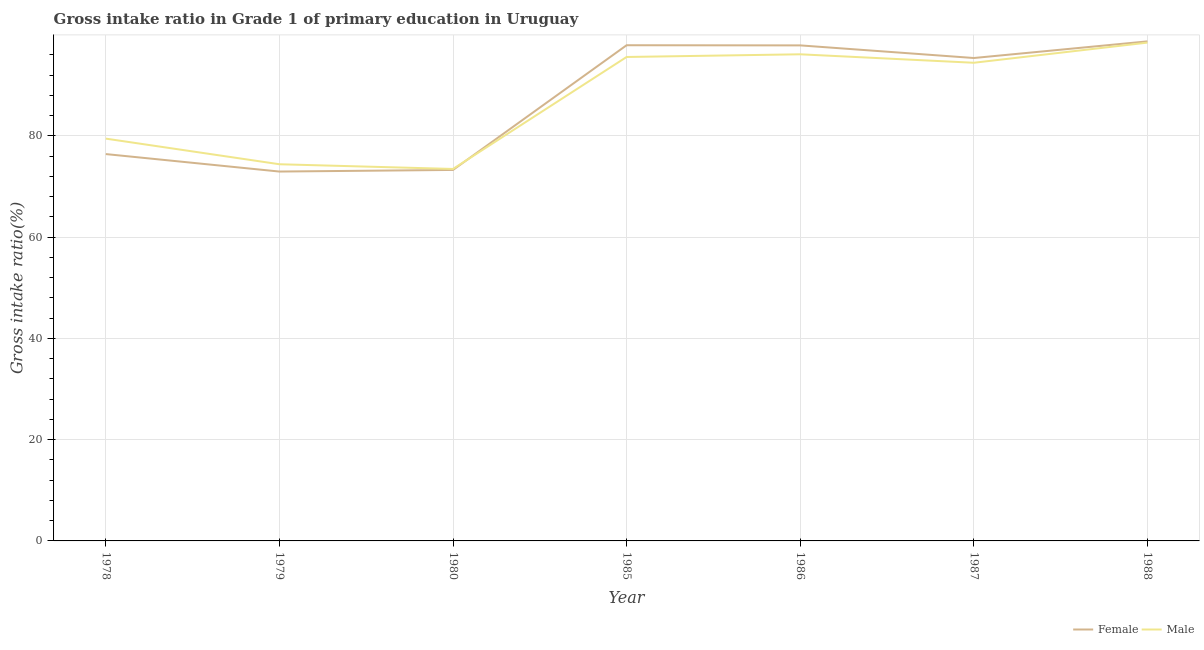What is the gross intake ratio(male) in 1980?
Provide a short and direct response. 73.45. Across all years, what is the maximum gross intake ratio(female)?
Make the answer very short. 98.64. Across all years, what is the minimum gross intake ratio(male)?
Offer a terse response. 73.45. In which year was the gross intake ratio(male) minimum?
Provide a succinct answer. 1980. What is the total gross intake ratio(male) in the graph?
Provide a succinct answer. 611.72. What is the difference between the gross intake ratio(female) in 1978 and that in 1988?
Make the answer very short. -22.25. What is the difference between the gross intake ratio(female) in 1980 and the gross intake ratio(male) in 1985?
Ensure brevity in your answer.  -22.31. What is the average gross intake ratio(female) per year?
Provide a succinct answer. 87.47. In the year 1980, what is the difference between the gross intake ratio(male) and gross intake ratio(female)?
Your answer should be very brief. 0.19. What is the ratio of the gross intake ratio(female) in 1978 to that in 1985?
Your answer should be very brief. 0.78. What is the difference between the highest and the second highest gross intake ratio(female)?
Your answer should be compact. 0.76. What is the difference between the highest and the lowest gross intake ratio(male)?
Ensure brevity in your answer.  24.95. Is the sum of the gross intake ratio(female) in 1978 and 1986 greater than the maximum gross intake ratio(male) across all years?
Ensure brevity in your answer.  Yes. Is the gross intake ratio(male) strictly greater than the gross intake ratio(female) over the years?
Provide a succinct answer. No. How many lines are there?
Offer a very short reply. 2. How many years are there in the graph?
Keep it short and to the point. 7. What is the difference between two consecutive major ticks on the Y-axis?
Make the answer very short. 20. Are the values on the major ticks of Y-axis written in scientific E-notation?
Ensure brevity in your answer.  No. Does the graph contain any zero values?
Give a very brief answer. No. Does the graph contain grids?
Your response must be concise. Yes. Where does the legend appear in the graph?
Keep it short and to the point. Bottom right. How many legend labels are there?
Provide a succinct answer. 2. How are the legend labels stacked?
Your answer should be compact. Horizontal. What is the title of the graph?
Offer a very short reply. Gross intake ratio in Grade 1 of primary education in Uruguay. Does "Primary" appear as one of the legend labels in the graph?
Offer a terse response. No. What is the label or title of the X-axis?
Keep it short and to the point. Year. What is the label or title of the Y-axis?
Make the answer very short. Gross intake ratio(%). What is the Gross intake ratio(%) in Female in 1978?
Provide a short and direct response. 76.39. What is the Gross intake ratio(%) of Male in 1978?
Offer a terse response. 79.44. What is the Gross intake ratio(%) of Female in 1979?
Keep it short and to the point. 72.94. What is the Gross intake ratio(%) in Male in 1979?
Provide a short and direct response. 74.38. What is the Gross intake ratio(%) in Female in 1980?
Provide a short and direct response. 73.25. What is the Gross intake ratio(%) of Male in 1980?
Your answer should be compact. 73.45. What is the Gross intake ratio(%) in Female in 1985?
Offer a terse response. 97.88. What is the Gross intake ratio(%) of Male in 1985?
Provide a short and direct response. 95.56. What is the Gross intake ratio(%) of Female in 1986?
Offer a terse response. 97.85. What is the Gross intake ratio(%) in Male in 1986?
Make the answer very short. 96.09. What is the Gross intake ratio(%) in Female in 1987?
Your answer should be very brief. 95.36. What is the Gross intake ratio(%) of Male in 1987?
Provide a succinct answer. 94.42. What is the Gross intake ratio(%) of Female in 1988?
Offer a terse response. 98.64. What is the Gross intake ratio(%) of Male in 1988?
Your answer should be compact. 98.39. Across all years, what is the maximum Gross intake ratio(%) of Female?
Your answer should be compact. 98.64. Across all years, what is the maximum Gross intake ratio(%) of Male?
Your answer should be very brief. 98.39. Across all years, what is the minimum Gross intake ratio(%) in Female?
Give a very brief answer. 72.94. Across all years, what is the minimum Gross intake ratio(%) in Male?
Your response must be concise. 73.45. What is the total Gross intake ratio(%) of Female in the graph?
Your response must be concise. 612.3. What is the total Gross intake ratio(%) in Male in the graph?
Provide a succinct answer. 611.72. What is the difference between the Gross intake ratio(%) of Female in 1978 and that in 1979?
Keep it short and to the point. 3.45. What is the difference between the Gross intake ratio(%) of Male in 1978 and that in 1979?
Offer a very short reply. 5.06. What is the difference between the Gross intake ratio(%) in Female in 1978 and that in 1980?
Ensure brevity in your answer.  3.13. What is the difference between the Gross intake ratio(%) of Male in 1978 and that in 1980?
Give a very brief answer. 5.99. What is the difference between the Gross intake ratio(%) of Female in 1978 and that in 1985?
Make the answer very short. -21.49. What is the difference between the Gross intake ratio(%) of Male in 1978 and that in 1985?
Offer a very short reply. -16.12. What is the difference between the Gross intake ratio(%) of Female in 1978 and that in 1986?
Make the answer very short. -21.46. What is the difference between the Gross intake ratio(%) in Male in 1978 and that in 1986?
Your answer should be very brief. -16.65. What is the difference between the Gross intake ratio(%) of Female in 1978 and that in 1987?
Offer a very short reply. -18.97. What is the difference between the Gross intake ratio(%) in Male in 1978 and that in 1987?
Your answer should be very brief. -14.98. What is the difference between the Gross intake ratio(%) in Female in 1978 and that in 1988?
Your response must be concise. -22.25. What is the difference between the Gross intake ratio(%) of Male in 1978 and that in 1988?
Make the answer very short. -18.96. What is the difference between the Gross intake ratio(%) of Female in 1979 and that in 1980?
Keep it short and to the point. -0.32. What is the difference between the Gross intake ratio(%) in Male in 1979 and that in 1980?
Make the answer very short. 0.93. What is the difference between the Gross intake ratio(%) of Female in 1979 and that in 1985?
Offer a terse response. -24.94. What is the difference between the Gross intake ratio(%) of Male in 1979 and that in 1985?
Give a very brief answer. -21.18. What is the difference between the Gross intake ratio(%) in Female in 1979 and that in 1986?
Keep it short and to the point. -24.91. What is the difference between the Gross intake ratio(%) of Male in 1979 and that in 1986?
Make the answer very short. -21.71. What is the difference between the Gross intake ratio(%) of Female in 1979 and that in 1987?
Provide a short and direct response. -22.42. What is the difference between the Gross intake ratio(%) of Male in 1979 and that in 1987?
Ensure brevity in your answer.  -20.04. What is the difference between the Gross intake ratio(%) in Female in 1979 and that in 1988?
Offer a terse response. -25.7. What is the difference between the Gross intake ratio(%) in Male in 1979 and that in 1988?
Offer a very short reply. -24.02. What is the difference between the Gross intake ratio(%) in Female in 1980 and that in 1985?
Make the answer very short. -24.62. What is the difference between the Gross intake ratio(%) in Male in 1980 and that in 1985?
Make the answer very short. -22.11. What is the difference between the Gross intake ratio(%) in Female in 1980 and that in 1986?
Your response must be concise. -24.59. What is the difference between the Gross intake ratio(%) in Male in 1980 and that in 1986?
Your answer should be compact. -22.64. What is the difference between the Gross intake ratio(%) of Female in 1980 and that in 1987?
Keep it short and to the point. -22.1. What is the difference between the Gross intake ratio(%) of Male in 1980 and that in 1987?
Provide a short and direct response. -20.97. What is the difference between the Gross intake ratio(%) of Female in 1980 and that in 1988?
Keep it short and to the point. -25.38. What is the difference between the Gross intake ratio(%) of Male in 1980 and that in 1988?
Offer a terse response. -24.95. What is the difference between the Gross intake ratio(%) in Female in 1985 and that in 1986?
Make the answer very short. 0.03. What is the difference between the Gross intake ratio(%) in Male in 1985 and that in 1986?
Provide a succinct answer. -0.53. What is the difference between the Gross intake ratio(%) of Female in 1985 and that in 1987?
Provide a short and direct response. 2.52. What is the difference between the Gross intake ratio(%) in Male in 1985 and that in 1987?
Provide a succinct answer. 1.14. What is the difference between the Gross intake ratio(%) of Female in 1985 and that in 1988?
Your answer should be very brief. -0.76. What is the difference between the Gross intake ratio(%) in Male in 1985 and that in 1988?
Offer a terse response. -2.83. What is the difference between the Gross intake ratio(%) in Female in 1986 and that in 1987?
Offer a very short reply. 2.49. What is the difference between the Gross intake ratio(%) in Male in 1986 and that in 1987?
Offer a very short reply. 1.67. What is the difference between the Gross intake ratio(%) of Female in 1986 and that in 1988?
Make the answer very short. -0.79. What is the difference between the Gross intake ratio(%) of Male in 1986 and that in 1988?
Keep it short and to the point. -2.31. What is the difference between the Gross intake ratio(%) in Female in 1987 and that in 1988?
Give a very brief answer. -3.28. What is the difference between the Gross intake ratio(%) in Male in 1987 and that in 1988?
Ensure brevity in your answer.  -3.98. What is the difference between the Gross intake ratio(%) in Female in 1978 and the Gross intake ratio(%) in Male in 1979?
Provide a short and direct response. 2.01. What is the difference between the Gross intake ratio(%) in Female in 1978 and the Gross intake ratio(%) in Male in 1980?
Your answer should be compact. 2.94. What is the difference between the Gross intake ratio(%) in Female in 1978 and the Gross intake ratio(%) in Male in 1985?
Your response must be concise. -19.17. What is the difference between the Gross intake ratio(%) in Female in 1978 and the Gross intake ratio(%) in Male in 1986?
Offer a terse response. -19.7. What is the difference between the Gross intake ratio(%) in Female in 1978 and the Gross intake ratio(%) in Male in 1987?
Your response must be concise. -18.03. What is the difference between the Gross intake ratio(%) of Female in 1978 and the Gross intake ratio(%) of Male in 1988?
Your response must be concise. -22.01. What is the difference between the Gross intake ratio(%) in Female in 1979 and the Gross intake ratio(%) in Male in 1980?
Your answer should be compact. -0.51. What is the difference between the Gross intake ratio(%) of Female in 1979 and the Gross intake ratio(%) of Male in 1985?
Your answer should be very brief. -22.62. What is the difference between the Gross intake ratio(%) in Female in 1979 and the Gross intake ratio(%) in Male in 1986?
Provide a short and direct response. -23.15. What is the difference between the Gross intake ratio(%) of Female in 1979 and the Gross intake ratio(%) of Male in 1987?
Your answer should be compact. -21.48. What is the difference between the Gross intake ratio(%) of Female in 1979 and the Gross intake ratio(%) of Male in 1988?
Ensure brevity in your answer.  -25.46. What is the difference between the Gross intake ratio(%) of Female in 1980 and the Gross intake ratio(%) of Male in 1985?
Your response must be concise. -22.31. What is the difference between the Gross intake ratio(%) in Female in 1980 and the Gross intake ratio(%) in Male in 1986?
Ensure brevity in your answer.  -22.83. What is the difference between the Gross intake ratio(%) of Female in 1980 and the Gross intake ratio(%) of Male in 1987?
Your response must be concise. -21.16. What is the difference between the Gross intake ratio(%) of Female in 1980 and the Gross intake ratio(%) of Male in 1988?
Provide a succinct answer. -25.14. What is the difference between the Gross intake ratio(%) in Female in 1985 and the Gross intake ratio(%) in Male in 1986?
Provide a short and direct response. 1.79. What is the difference between the Gross intake ratio(%) of Female in 1985 and the Gross intake ratio(%) of Male in 1987?
Make the answer very short. 3.46. What is the difference between the Gross intake ratio(%) in Female in 1985 and the Gross intake ratio(%) in Male in 1988?
Provide a short and direct response. -0.52. What is the difference between the Gross intake ratio(%) in Female in 1986 and the Gross intake ratio(%) in Male in 1987?
Make the answer very short. 3.43. What is the difference between the Gross intake ratio(%) in Female in 1986 and the Gross intake ratio(%) in Male in 1988?
Offer a terse response. -0.55. What is the difference between the Gross intake ratio(%) in Female in 1987 and the Gross intake ratio(%) in Male in 1988?
Offer a very short reply. -3.04. What is the average Gross intake ratio(%) of Female per year?
Give a very brief answer. 87.47. What is the average Gross intake ratio(%) in Male per year?
Ensure brevity in your answer.  87.39. In the year 1978, what is the difference between the Gross intake ratio(%) of Female and Gross intake ratio(%) of Male?
Offer a very short reply. -3.05. In the year 1979, what is the difference between the Gross intake ratio(%) in Female and Gross intake ratio(%) in Male?
Your answer should be compact. -1.44. In the year 1980, what is the difference between the Gross intake ratio(%) of Female and Gross intake ratio(%) of Male?
Your answer should be compact. -0.19. In the year 1985, what is the difference between the Gross intake ratio(%) of Female and Gross intake ratio(%) of Male?
Provide a succinct answer. 2.32. In the year 1986, what is the difference between the Gross intake ratio(%) in Female and Gross intake ratio(%) in Male?
Make the answer very short. 1.76. In the year 1987, what is the difference between the Gross intake ratio(%) in Female and Gross intake ratio(%) in Male?
Give a very brief answer. 0.94. In the year 1988, what is the difference between the Gross intake ratio(%) in Female and Gross intake ratio(%) in Male?
Make the answer very short. 0.24. What is the ratio of the Gross intake ratio(%) in Female in 1978 to that in 1979?
Your answer should be very brief. 1.05. What is the ratio of the Gross intake ratio(%) in Male in 1978 to that in 1979?
Your response must be concise. 1.07. What is the ratio of the Gross intake ratio(%) of Female in 1978 to that in 1980?
Provide a short and direct response. 1.04. What is the ratio of the Gross intake ratio(%) in Male in 1978 to that in 1980?
Offer a very short reply. 1.08. What is the ratio of the Gross intake ratio(%) in Female in 1978 to that in 1985?
Ensure brevity in your answer.  0.78. What is the ratio of the Gross intake ratio(%) in Male in 1978 to that in 1985?
Your response must be concise. 0.83. What is the ratio of the Gross intake ratio(%) in Female in 1978 to that in 1986?
Give a very brief answer. 0.78. What is the ratio of the Gross intake ratio(%) in Male in 1978 to that in 1986?
Offer a very short reply. 0.83. What is the ratio of the Gross intake ratio(%) in Female in 1978 to that in 1987?
Offer a very short reply. 0.8. What is the ratio of the Gross intake ratio(%) of Male in 1978 to that in 1987?
Your response must be concise. 0.84. What is the ratio of the Gross intake ratio(%) of Female in 1978 to that in 1988?
Offer a terse response. 0.77. What is the ratio of the Gross intake ratio(%) in Male in 1978 to that in 1988?
Offer a very short reply. 0.81. What is the ratio of the Gross intake ratio(%) in Male in 1979 to that in 1980?
Your answer should be compact. 1.01. What is the ratio of the Gross intake ratio(%) of Female in 1979 to that in 1985?
Give a very brief answer. 0.75. What is the ratio of the Gross intake ratio(%) of Male in 1979 to that in 1985?
Make the answer very short. 0.78. What is the ratio of the Gross intake ratio(%) in Female in 1979 to that in 1986?
Offer a very short reply. 0.75. What is the ratio of the Gross intake ratio(%) of Male in 1979 to that in 1986?
Your response must be concise. 0.77. What is the ratio of the Gross intake ratio(%) of Female in 1979 to that in 1987?
Keep it short and to the point. 0.76. What is the ratio of the Gross intake ratio(%) of Male in 1979 to that in 1987?
Give a very brief answer. 0.79. What is the ratio of the Gross intake ratio(%) of Female in 1979 to that in 1988?
Keep it short and to the point. 0.74. What is the ratio of the Gross intake ratio(%) of Male in 1979 to that in 1988?
Give a very brief answer. 0.76. What is the ratio of the Gross intake ratio(%) in Female in 1980 to that in 1985?
Keep it short and to the point. 0.75. What is the ratio of the Gross intake ratio(%) of Male in 1980 to that in 1985?
Keep it short and to the point. 0.77. What is the ratio of the Gross intake ratio(%) of Female in 1980 to that in 1986?
Give a very brief answer. 0.75. What is the ratio of the Gross intake ratio(%) of Male in 1980 to that in 1986?
Your answer should be compact. 0.76. What is the ratio of the Gross intake ratio(%) in Female in 1980 to that in 1987?
Ensure brevity in your answer.  0.77. What is the ratio of the Gross intake ratio(%) of Male in 1980 to that in 1987?
Your answer should be compact. 0.78. What is the ratio of the Gross intake ratio(%) in Female in 1980 to that in 1988?
Your response must be concise. 0.74. What is the ratio of the Gross intake ratio(%) of Male in 1980 to that in 1988?
Offer a very short reply. 0.75. What is the ratio of the Gross intake ratio(%) of Female in 1985 to that in 1986?
Your answer should be compact. 1. What is the ratio of the Gross intake ratio(%) of Male in 1985 to that in 1986?
Keep it short and to the point. 0.99. What is the ratio of the Gross intake ratio(%) of Female in 1985 to that in 1987?
Your answer should be compact. 1.03. What is the ratio of the Gross intake ratio(%) of Male in 1985 to that in 1987?
Your answer should be very brief. 1.01. What is the ratio of the Gross intake ratio(%) in Female in 1985 to that in 1988?
Keep it short and to the point. 0.99. What is the ratio of the Gross intake ratio(%) of Male in 1985 to that in 1988?
Your response must be concise. 0.97. What is the ratio of the Gross intake ratio(%) in Female in 1986 to that in 1987?
Your answer should be very brief. 1.03. What is the ratio of the Gross intake ratio(%) of Male in 1986 to that in 1987?
Offer a terse response. 1.02. What is the ratio of the Gross intake ratio(%) in Female in 1986 to that in 1988?
Ensure brevity in your answer.  0.99. What is the ratio of the Gross intake ratio(%) of Male in 1986 to that in 1988?
Your answer should be very brief. 0.98. What is the ratio of the Gross intake ratio(%) in Female in 1987 to that in 1988?
Provide a succinct answer. 0.97. What is the ratio of the Gross intake ratio(%) in Male in 1987 to that in 1988?
Provide a succinct answer. 0.96. What is the difference between the highest and the second highest Gross intake ratio(%) in Female?
Provide a succinct answer. 0.76. What is the difference between the highest and the second highest Gross intake ratio(%) in Male?
Make the answer very short. 2.31. What is the difference between the highest and the lowest Gross intake ratio(%) of Female?
Make the answer very short. 25.7. What is the difference between the highest and the lowest Gross intake ratio(%) of Male?
Offer a very short reply. 24.95. 